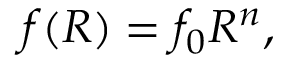Convert formula to latex. <formula><loc_0><loc_0><loc_500><loc_500>f ( R ) = f _ { 0 } R ^ { n } ,</formula> 